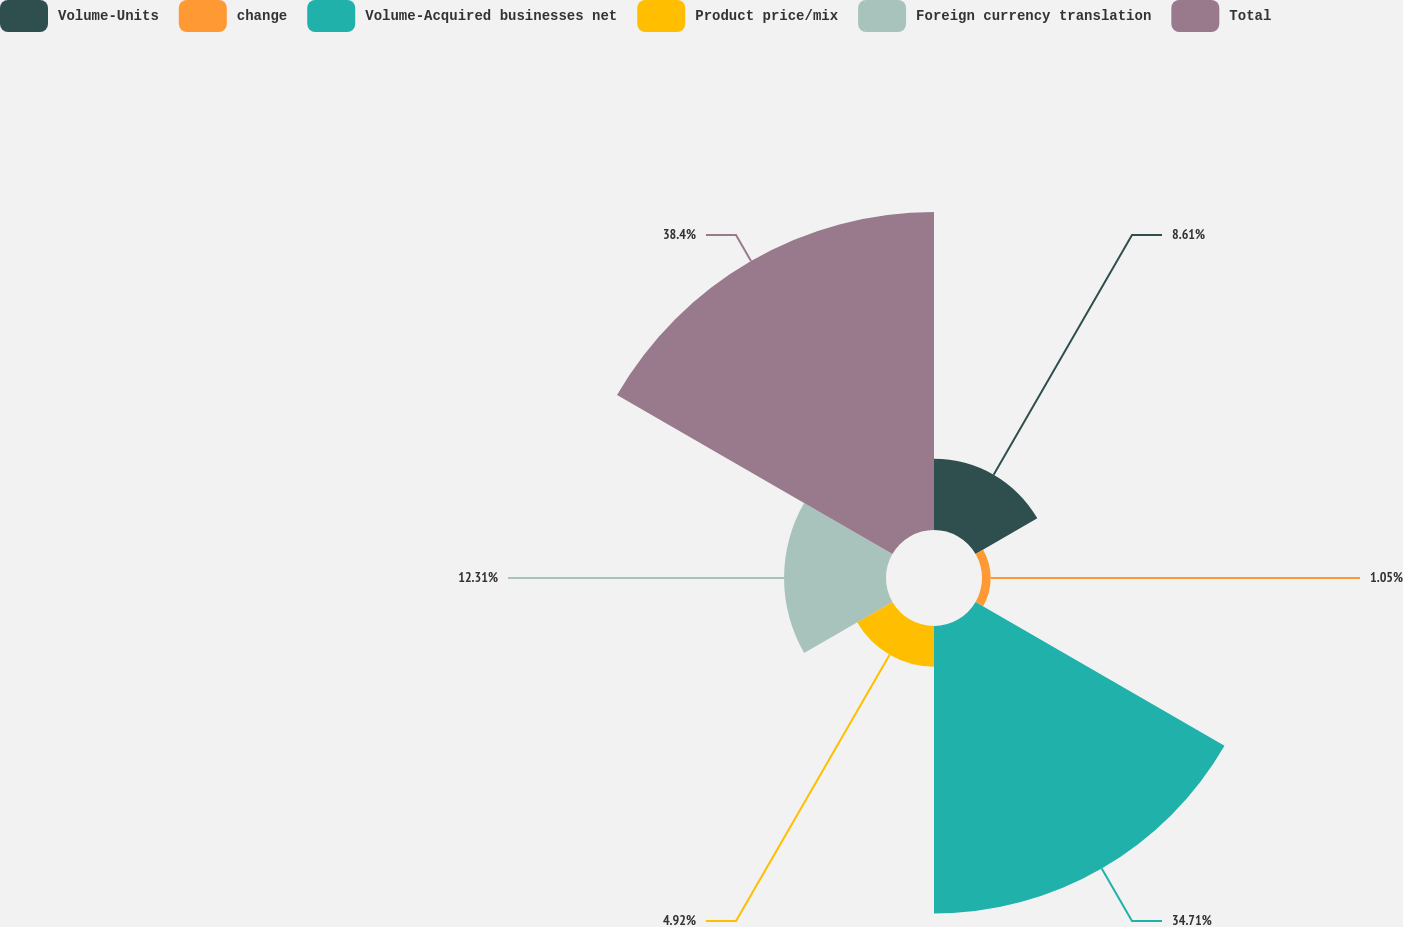Convert chart. <chart><loc_0><loc_0><loc_500><loc_500><pie_chart><fcel>Volume-Units<fcel>change<fcel>Volume-Acquired businesses net<fcel>Product price/mix<fcel>Foreign currency translation<fcel>Total<nl><fcel>8.61%<fcel>1.05%<fcel>34.71%<fcel>4.92%<fcel>12.31%<fcel>38.4%<nl></chart> 